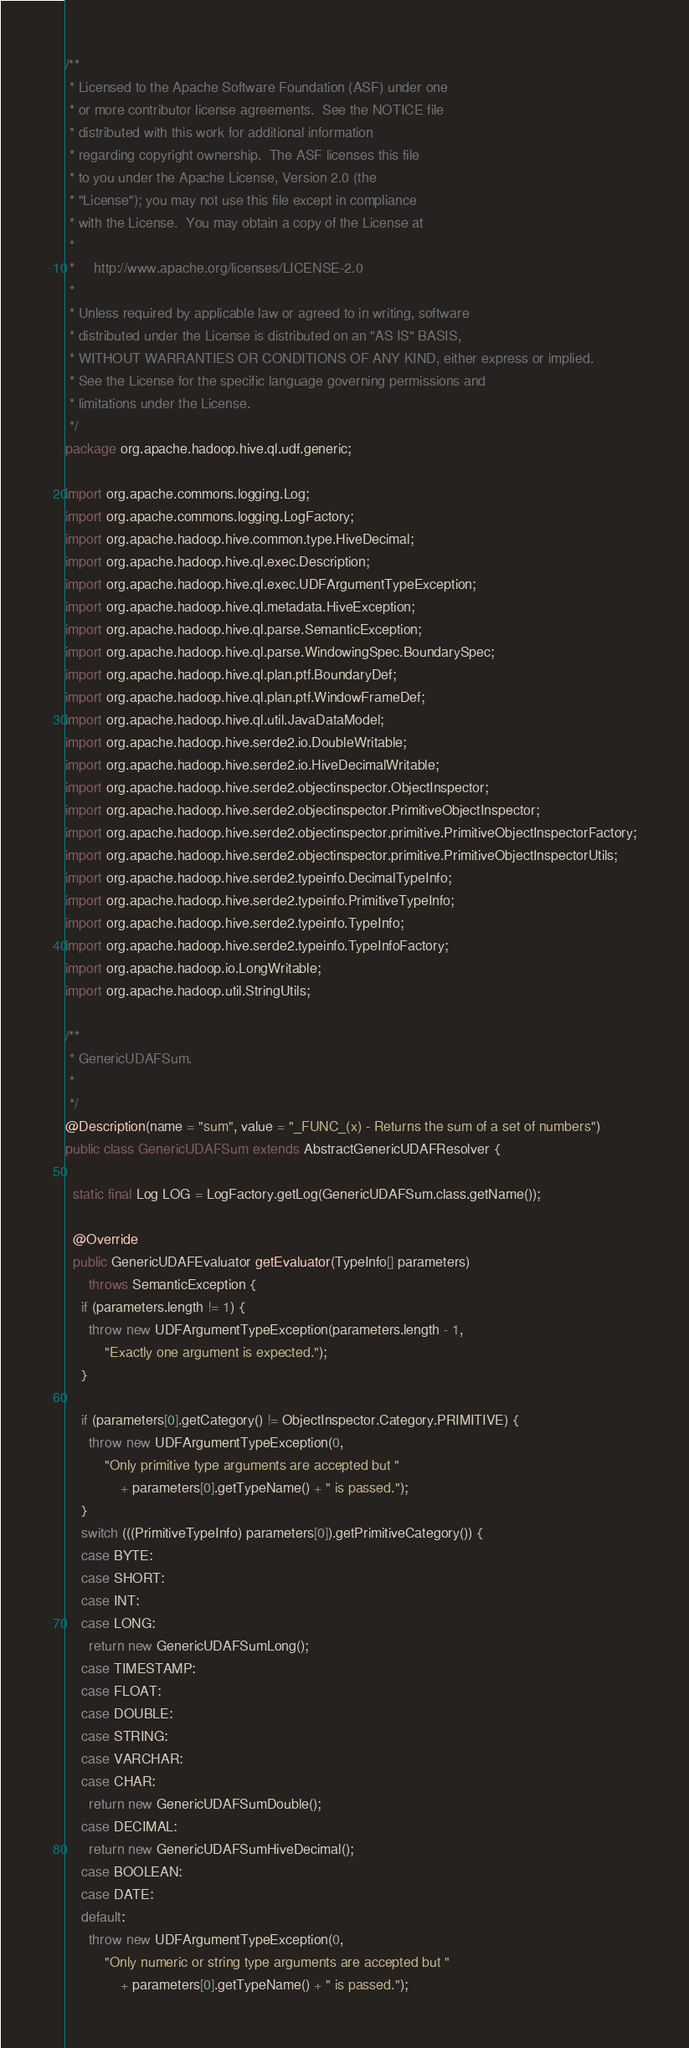Convert code to text. <code><loc_0><loc_0><loc_500><loc_500><_Java_>/**
 * Licensed to the Apache Software Foundation (ASF) under one
 * or more contributor license agreements.  See the NOTICE file
 * distributed with this work for additional information
 * regarding copyright ownership.  The ASF licenses this file
 * to you under the Apache License, Version 2.0 (the
 * "License"); you may not use this file except in compliance
 * with the License.  You may obtain a copy of the License at
 *
 *     http://www.apache.org/licenses/LICENSE-2.0
 *
 * Unless required by applicable law or agreed to in writing, software
 * distributed under the License is distributed on an "AS IS" BASIS,
 * WITHOUT WARRANTIES OR CONDITIONS OF ANY KIND, either express or implied.
 * See the License for the specific language governing permissions and
 * limitations under the License.
 */
package org.apache.hadoop.hive.ql.udf.generic;

import org.apache.commons.logging.Log;
import org.apache.commons.logging.LogFactory;
import org.apache.hadoop.hive.common.type.HiveDecimal;
import org.apache.hadoop.hive.ql.exec.Description;
import org.apache.hadoop.hive.ql.exec.UDFArgumentTypeException;
import org.apache.hadoop.hive.ql.metadata.HiveException;
import org.apache.hadoop.hive.ql.parse.SemanticException;
import org.apache.hadoop.hive.ql.parse.WindowingSpec.BoundarySpec;
import org.apache.hadoop.hive.ql.plan.ptf.BoundaryDef;
import org.apache.hadoop.hive.ql.plan.ptf.WindowFrameDef;
import org.apache.hadoop.hive.ql.util.JavaDataModel;
import org.apache.hadoop.hive.serde2.io.DoubleWritable;
import org.apache.hadoop.hive.serde2.io.HiveDecimalWritable;
import org.apache.hadoop.hive.serde2.objectinspector.ObjectInspector;
import org.apache.hadoop.hive.serde2.objectinspector.PrimitiveObjectInspector;
import org.apache.hadoop.hive.serde2.objectinspector.primitive.PrimitiveObjectInspectorFactory;
import org.apache.hadoop.hive.serde2.objectinspector.primitive.PrimitiveObjectInspectorUtils;
import org.apache.hadoop.hive.serde2.typeinfo.DecimalTypeInfo;
import org.apache.hadoop.hive.serde2.typeinfo.PrimitiveTypeInfo;
import org.apache.hadoop.hive.serde2.typeinfo.TypeInfo;
import org.apache.hadoop.hive.serde2.typeinfo.TypeInfoFactory;
import org.apache.hadoop.io.LongWritable;
import org.apache.hadoop.util.StringUtils;

/**
 * GenericUDAFSum.
 *
 */
@Description(name = "sum", value = "_FUNC_(x) - Returns the sum of a set of numbers")
public class GenericUDAFSum extends AbstractGenericUDAFResolver {

  static final Log LOG = LogFactory.getLog(GenericUDAFSum.class.getName());

  @Override
  public GenericUDAFEvaluator getEvaluator(TypeInfo[] parameters)
      throws SemanticException {
    if (parameters.length != 1) {
      throw new UDFArgumentTypeException(parameters.length - 1,
          "Exactly one argument is expected.");
    }

    if (parameters[0].getCategory() != ObjectInspector.Category.PRIMITIVE) {
      throw new UDFArgumentTypeException(0,
          "Only primitive type arguments are accepted but "
              + parameters[0].getTypeName() + " is passed.");
    }
    switch (((PrimitiveTypeInfo) parameters[0]).getPrimitiveCategory()) {
    case BYTE:
    case SHORT:
    case INT:
    case LONG:
      return new GenericUDAFSumLong();
    case TIMESTAMP:
    case FLOAT:
    case DOUBLE:
    case STRING:
    case VARCHAR:
    case CHAR:
      return new GenericUDAFSumDouble();
    case DECIMAL:
      return new GenericUDAFSumHiveDecimal();
    case BOOLEAN:
    case DATE:
    default:
      throw new UDFArgumentTypeException(0,
          "Only numeric or string type arguments are accepted but "
              + parameters[0].getTypeName() + " is passed.");</code> 